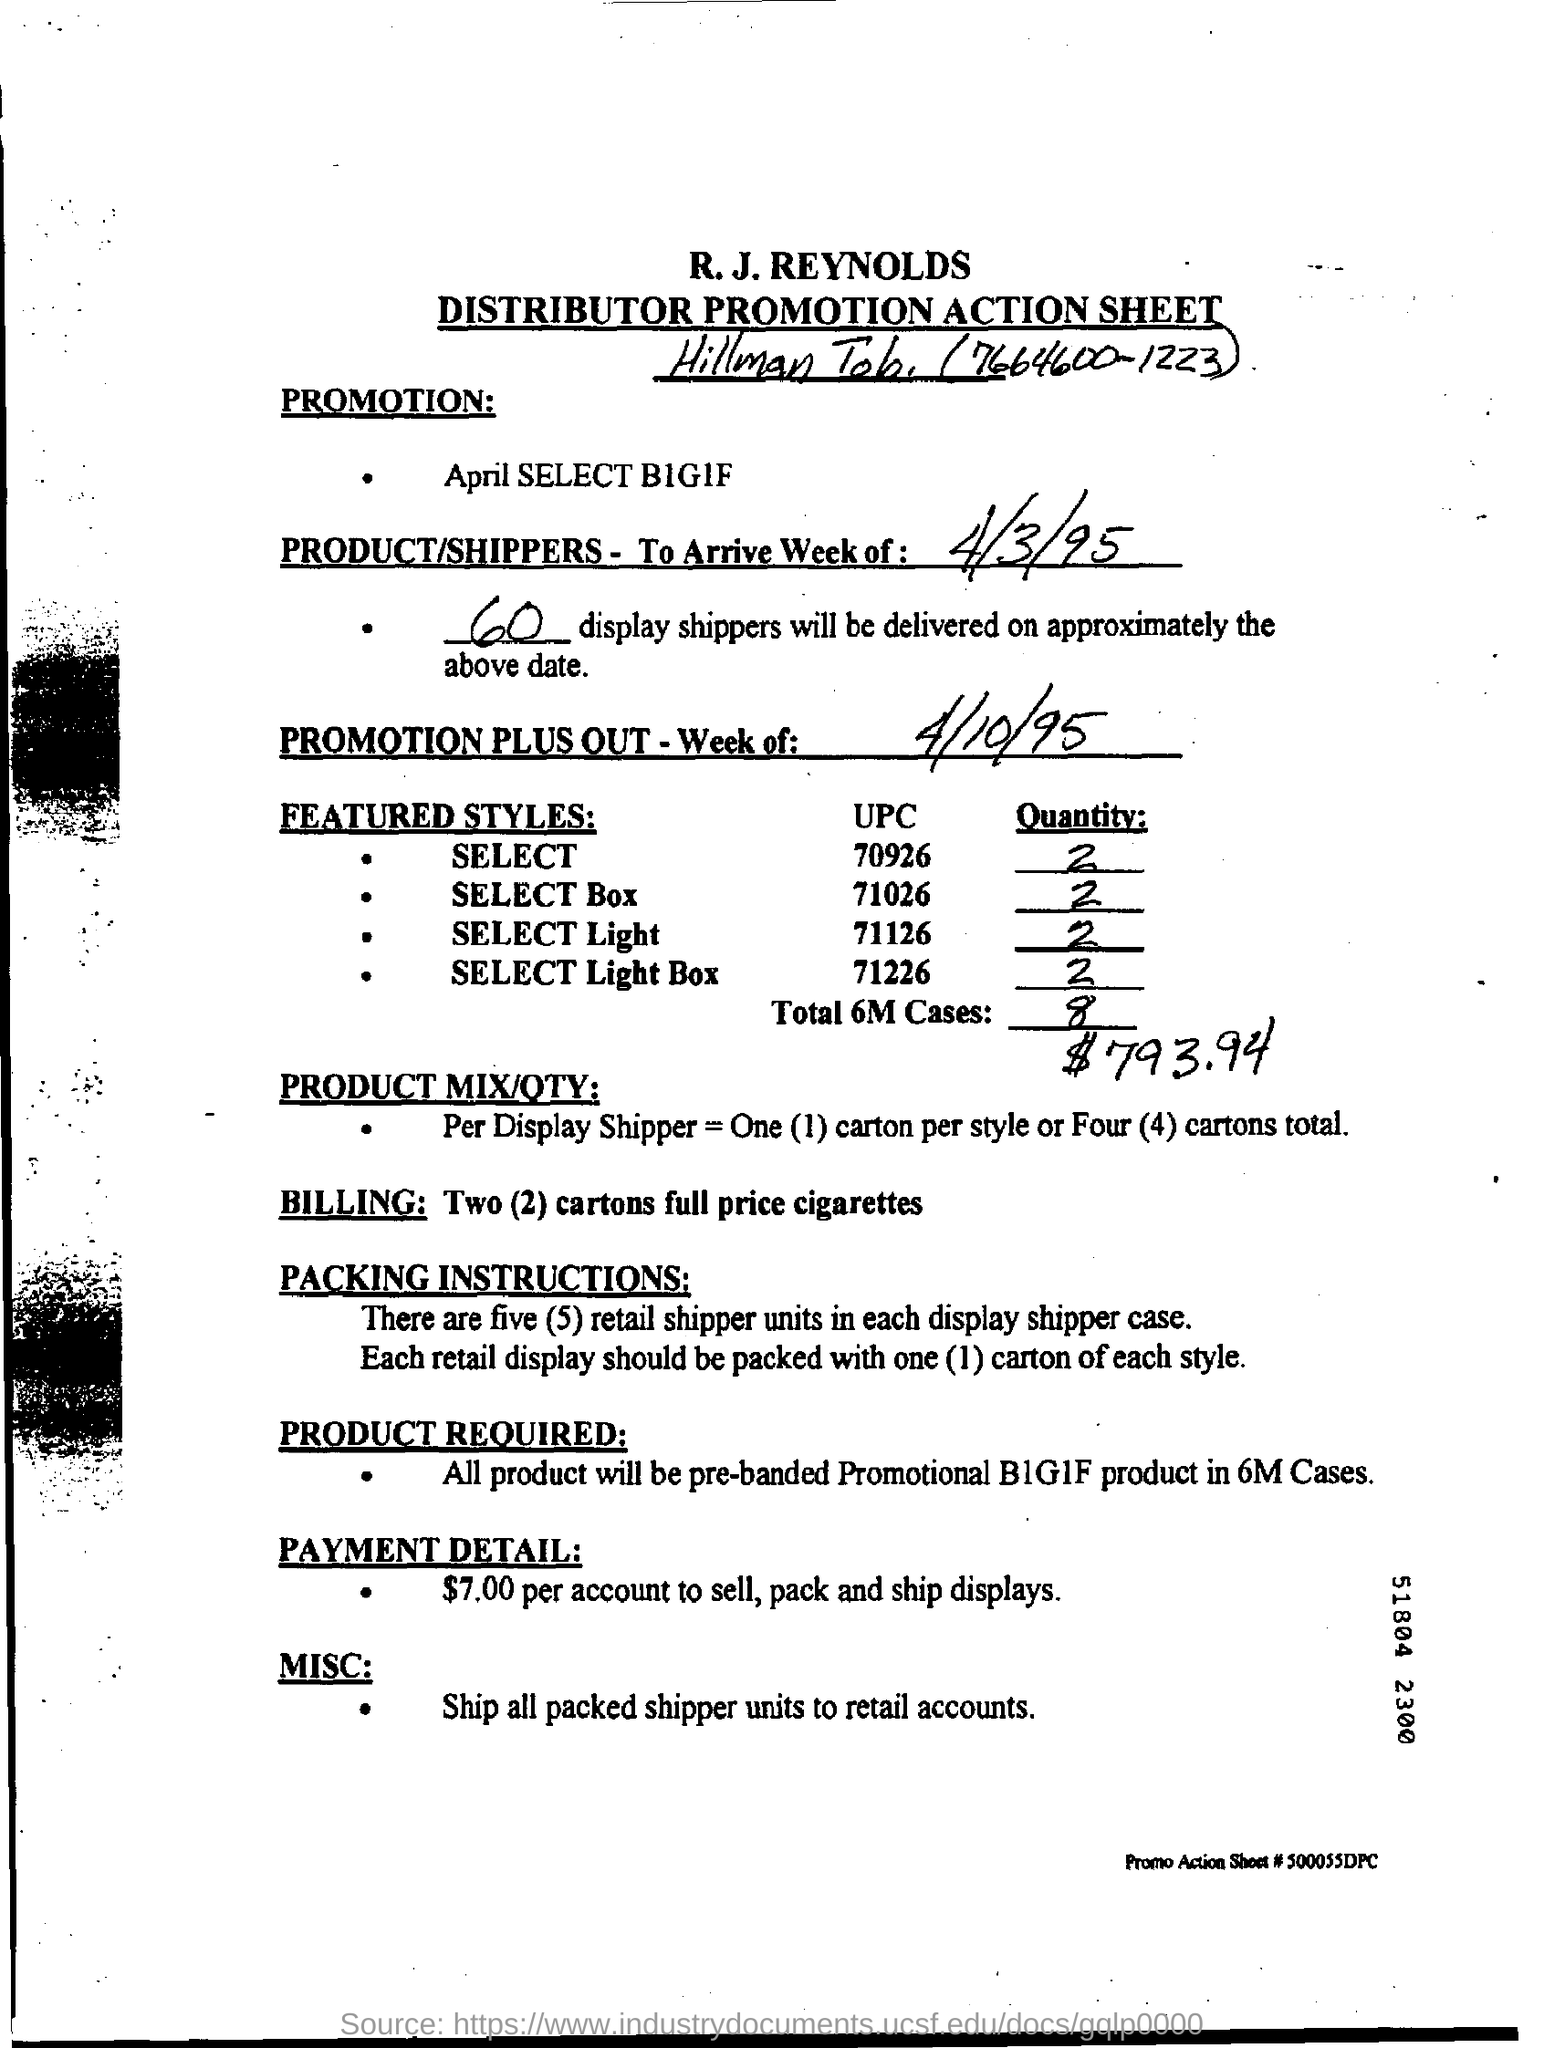What is the payment detail given in the form?
Your answer should be compact. $7.00 per account to sell, pack and ship displays. What is the second title in the document?
Provide a short and direct response. Distributor Promotion Action Sheet. 